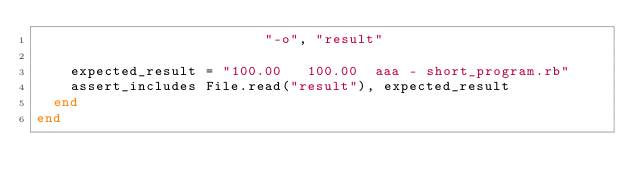<code> <loc_0><loc_0><loc_500><loc_500><_Ruby_>                           "-o", "result"

    expected_result = "100.00   100.00  aaa - short_program.rb"
    assert_includes File.read("result"), expected_result
  end
end
</code> 